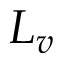<formula> <loc_0><loc_0><loc_500><loc_500>L _ { v }</formula> 